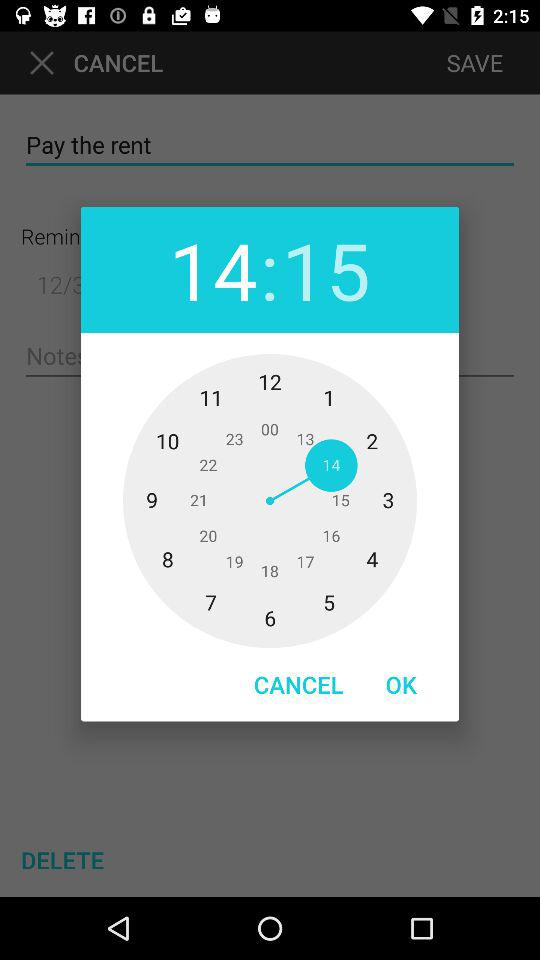How much rent is due?
When the provided information is insufficient, respond with <no answer>. <no answer> 